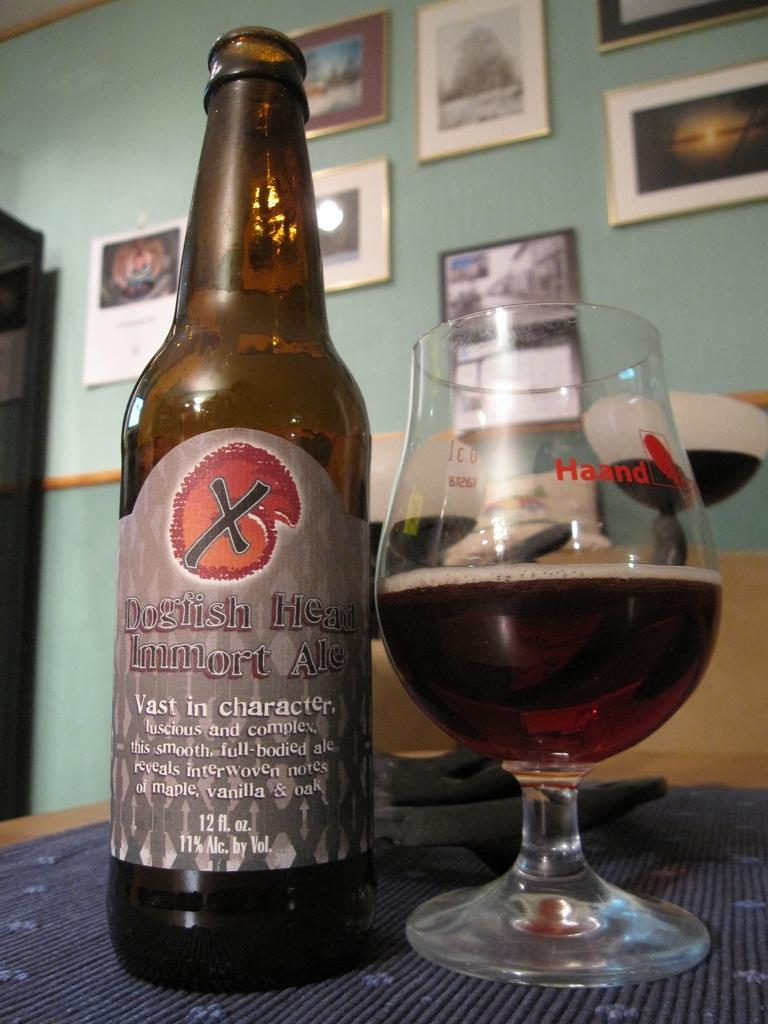What is present on the table in the image? There is a bottle and a glass filled with a drink on the table in the image. What type of container is the drink in? The drink is in a glass. What is the other object on the table? There is a bottle on the table. What can be seen in the background of the image? There are frames hanging on the wall in the background of the image. What type of oil is being used to roll the degree in the image? There is no oil, rolling, or degree present in the image. 